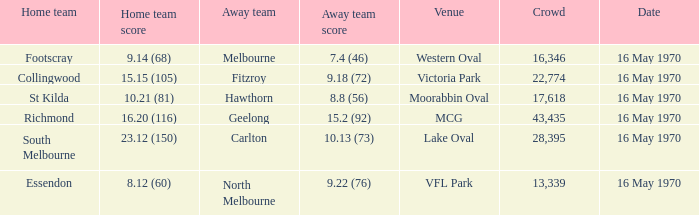14 (68)? Western Oval. 